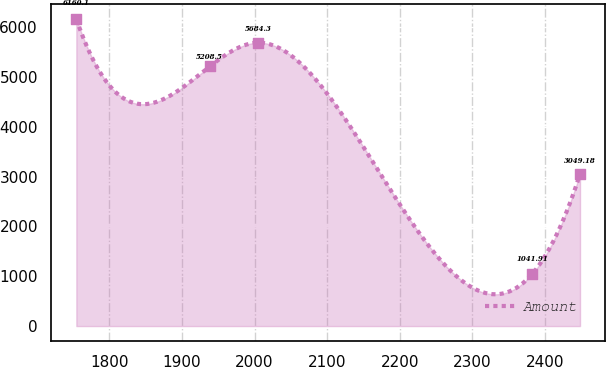Convert chart. <chart><loc_0><loc_0><loc_500><loc_500><line_chart><ecel><fcel>Amount<nl><fcel>1754.31<fcel>6160.1<nl><fcel>1938.25<fcel>5208.5<nl><fcel>2004.43<fcel>5684.3<nl><fcel>2382.41<fcel>1041.91<nl><fcel>2448.59<fcel>3049.18<nl></chart> 